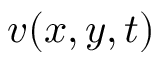<formula> <loc_0><loc_0><loc_500><loc_500>v ( x , y , t )</formula> 